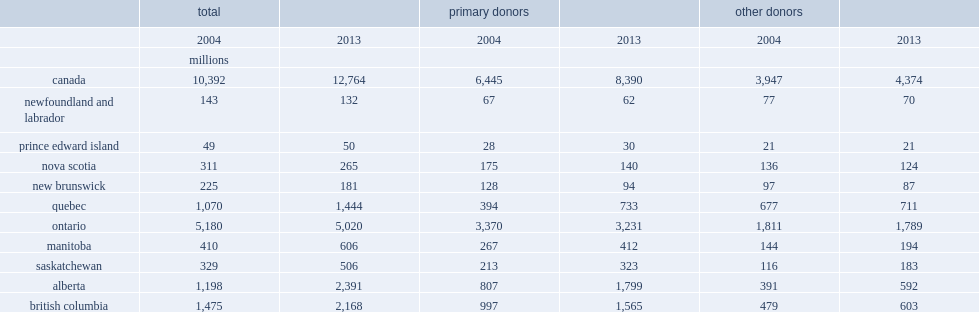What percentage did the total donations made by primary donors rise from 2004 to 2013? 0.301784. What percentage did other donors increase from 2004 to 2013? 0.108183. What percentage did the total amount of donations made in 2013 come from primary donors? 0.657317. What percentage did the total amount of donations made in 2004 come from primary donors? 0.620189. 